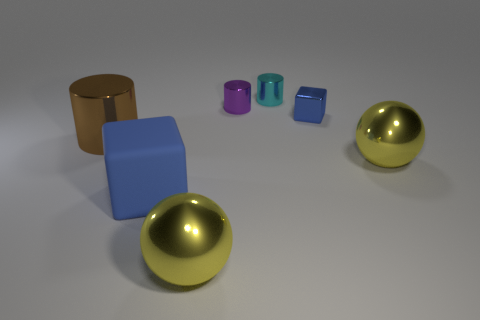What shape is the matte thing that is the same size as the brown metal thing? The matte object that matches the size of the brown metal item is a blue cube. This shape is characterized by its equal-length edges and right angles between its faces. 